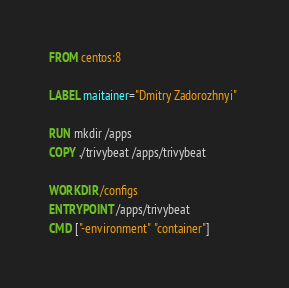Convert code to text. <code><loc_0><loc_0><loc_500><loc_500><_Dockerfile_>FROM centos:8

LABEL maitainer="Dmitry Zadorozhnyi" 

RUN mkdir /apps
COPY ./trivybeat /apps/trivybeat

WORKDIR /configs
ENTRYPOINT /apps/trivybeat
CMD ["-environment" "container"]
</code> 